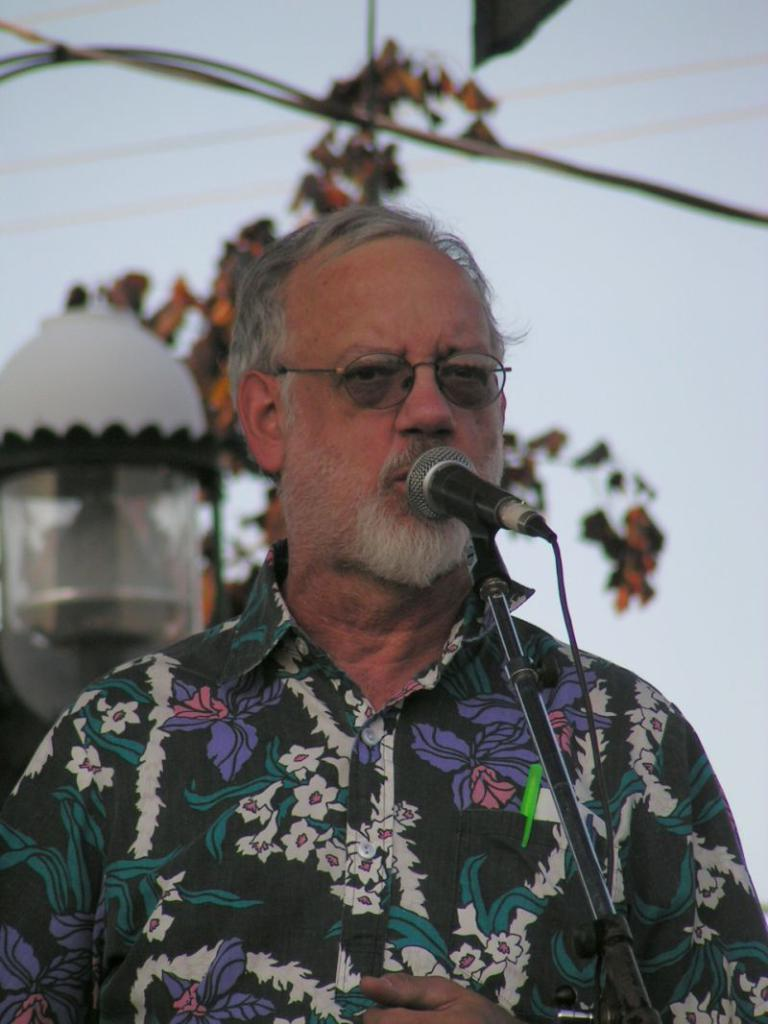What is the main subject of the image? The main subject of the image is a man standing in the middle of the image. What is the man doing in the image? The man is standing in front of a microphone. What can be seen in the background of the image? There is a tower, trees, electric wires, and the sky visible in the background of the image. What type of scent can be detected coming from the man in the image? There is no indication of any scent in the image, and it is not possible to determine what the man might smell like. 